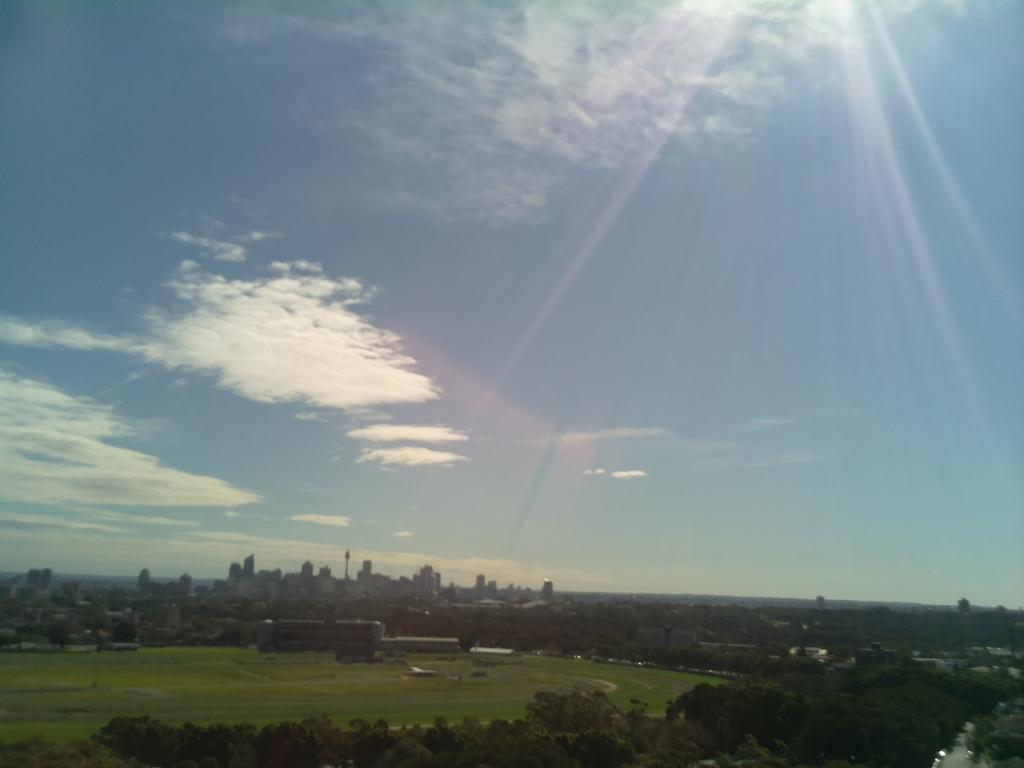What type of natural elements can be seen in the image? There are trees and the sky visible in the image. What is the ground like in the image? The ground is visible in the image. What type of man-made structures are present in the image? There are buildings in the image. What is the condition of the sky in the image? The sky is visible in the image, and there are clouds present. What can be seen coming from the sky in the image? Sun rays are present in the image. What type of finger can be seen pointing at the buildings in the image? There are no fingers present in the image; it only features trees, buildings, the sky, clouds, and sun rays. 